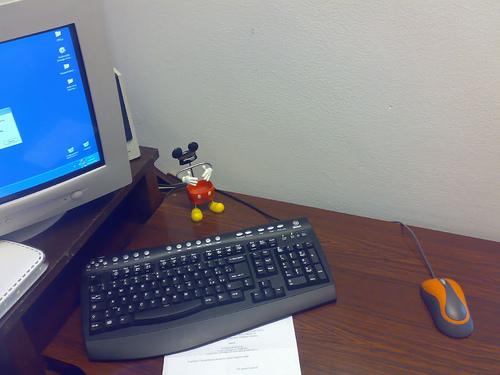What is on the desk?
Short answer required. Keyboard. Are there 2 monitors on this desk?
Give a very brief answer. No. What is Mickey mouse missing?
Short answer required. Head. What color is the desk?
Be succinct. Brown. 